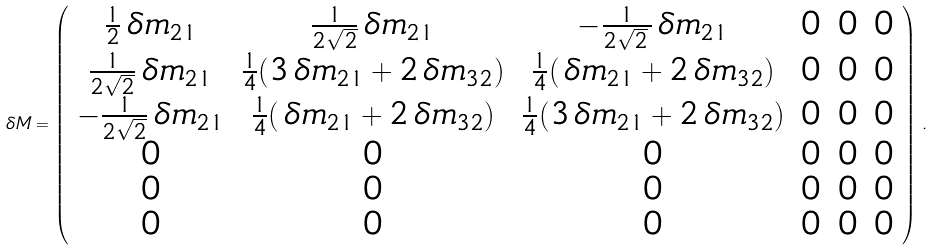<formula> <loc_0><loc_0><loc_500><loc_500>\, \delta M = \left ( \begin{array} { c c c c c c } \frac { 1 } { 2 } \, \delta m _ { 2 1 } & \frac { 1 } { 2 \sqrt { 2 } } \, \delta m _ { 2 1 } & - \frac { 1 } { 2 \sqrt { 2 } _ { \, } } \, \delta m _ { 2 1 } & 0 & 0 & 0 \\ \frac { 1 } { 2 \sqrt { 2 } } \, \delta m _ { 2 1 } & \frac { 1 } { 4 } ( 3 \, \delta m _ { 2 1 } + 2 \, \delta m _ { 3 2 } ) & \frac { 1 } { 4 } ( \, \delta m _ { 2 1 } + 2 \, \delta m _ { 3 2 } ) & 0 & 0 & 0 \\ - \frac { 1 } { 2 \sqrt { 2 } } \, \delta m _ { 2 1 } & \frac { 1 } { 4 } ( \, \delta m _ { 2 1 } + 2 \, \delta m _ { 3 2 } ) & \frac { 1 } { 4 } ( 3 \, \delta m _ { 2 1 } + 2 \, \delta m _ { 3 2 } ) & 0 & 0 & 0 \\ 0 & 0 & 0 & 0 & 0 & 0 \\ 0 & 0 & 0 & 0 & 0 & 0 \\ 0 & 0 & 0 & 0 & 0 & 0 \end{array} \right ) \, .</formula> 